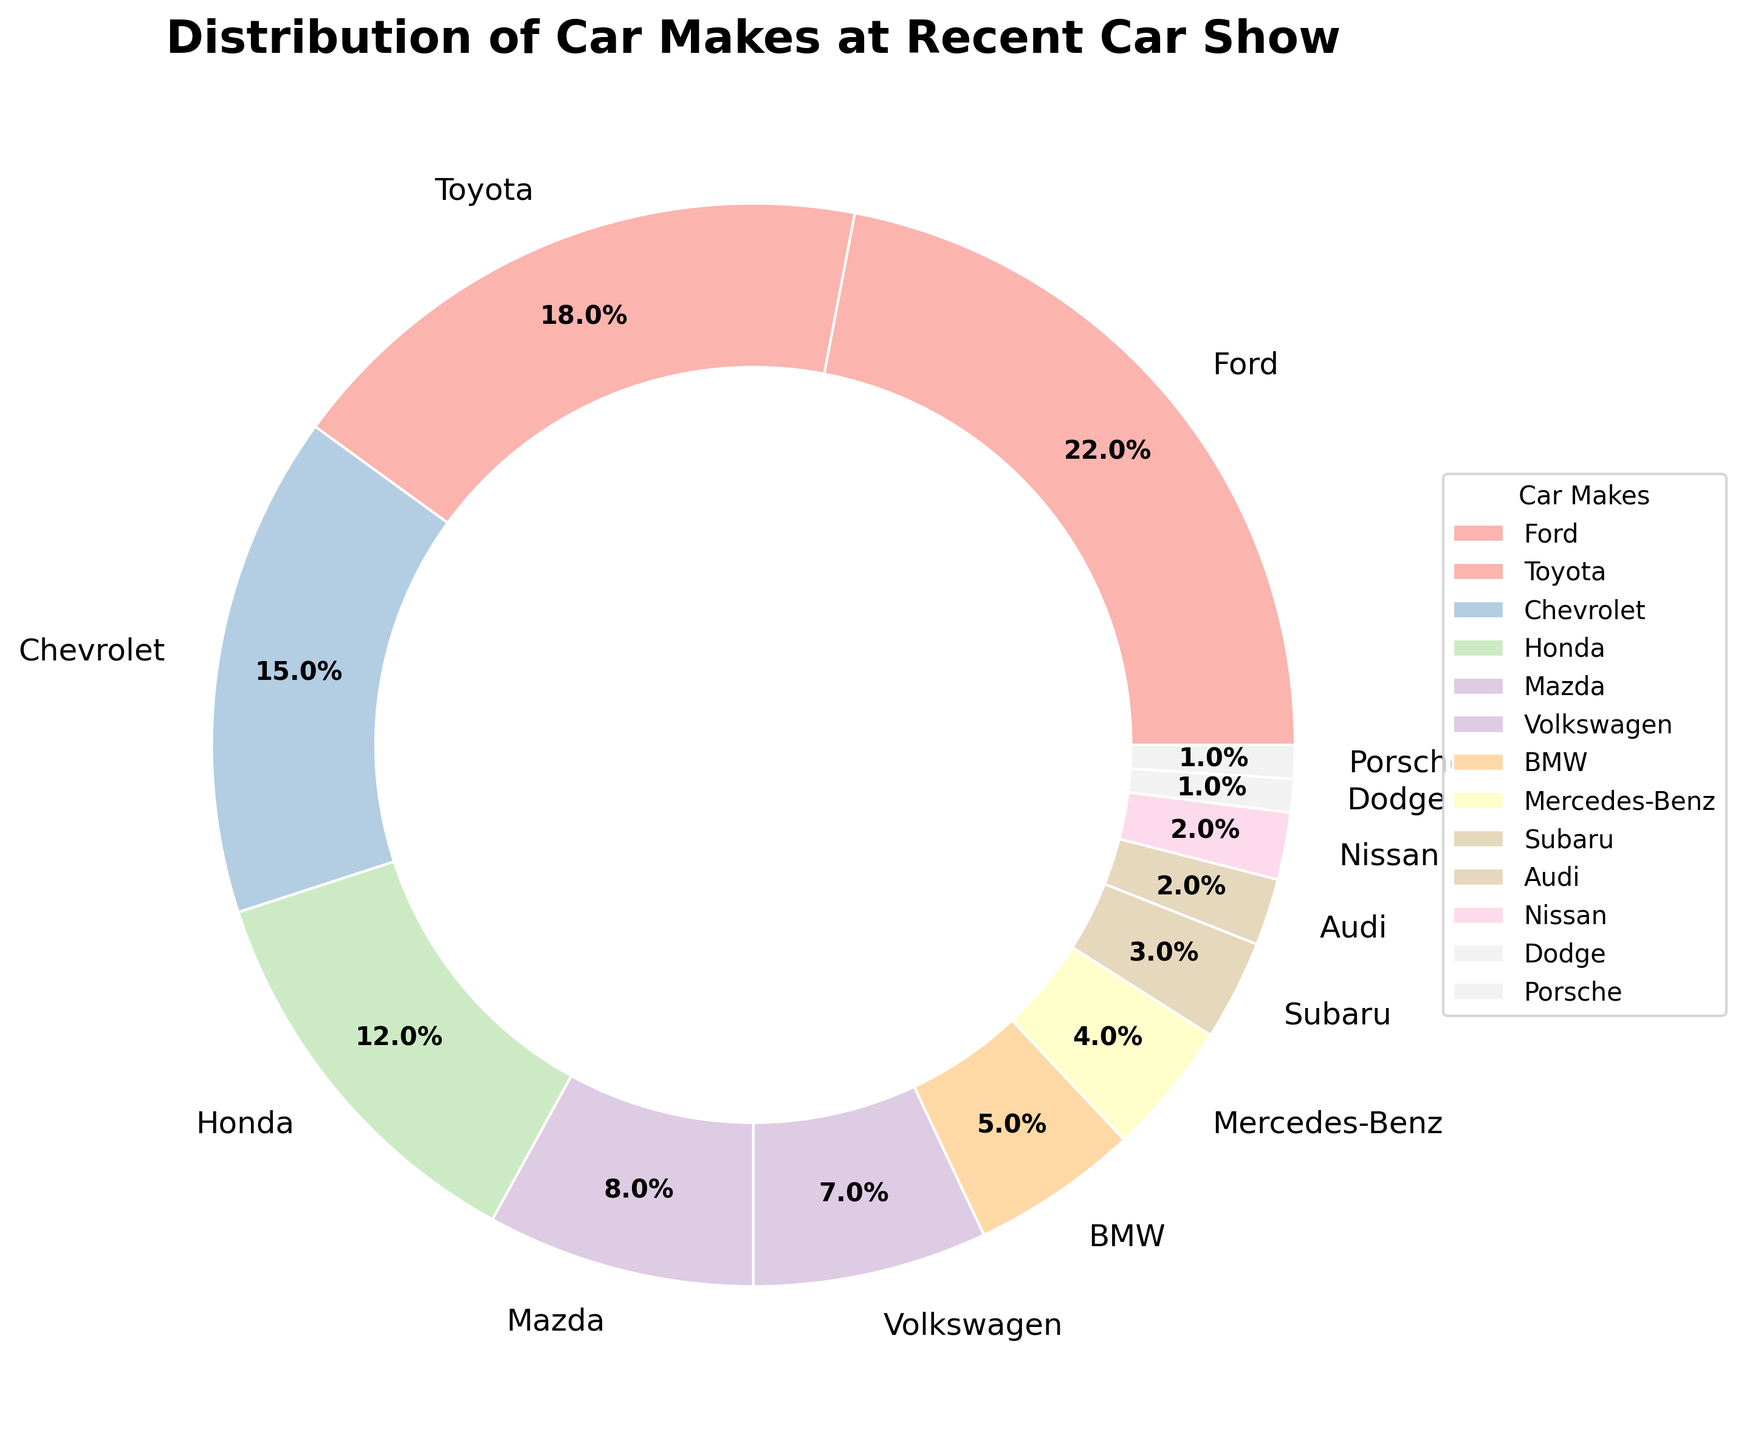Which car make has the largest representation at the car show? Looking at the pie chart, the largest wedge represents Ford. Its size and the percentage label (22%) are the largest among all the car makes.
Answer: Ford How many car makes have a representation of 5% or less? By visually inspecting the pie chart, we can identify the slices with percentages 5% or below: BMW (5%), Mercedes-Benz (4%), Subaru (3%), Audi (2%), Nissan (2%), Dodge (1%), and Porsche (1%). Counting these gives a total of 7 car makes.
Answer: 7 What is the difference in percentage between Ford and Toyota? The percentage for Ford is 22% and for Toyota is 18%. The difference is calculated as 22% - 18% = 4%.
Answer: 4% Which car makes together comprise exactly half of the total cars at the car show? By adding the percentages, we find that Ford (22%) + Toyota (18%) + Chevrolet (15%) = 55%. Individually, none of the combinations of other car makes sum to 50%, so the answer is none.
Answer: None Is the representation of Mazda greater than BMW? The representation of Mazda is 8%, whereas BMW is 5%. Comparatively, Mazda has a higher percentage than BMW.
Answer: Yes How many car makes combined make up 75% of the pie chart? Starting from the largest percentage, we add until reaching 75%: Ford (22%) + Toyota (18%) + Chevrolet (15%) + Honda (12%) + Mazda (8%) totals to 75%. These five car makes together account for 75%.
Answer: 5 What's the percentage difference between the least represented and the most represented car makes? The least represented are Dodge and Porsche at 1%, and the most represented is Ford at 22%. The percentage difference is 22% - 1% = 21%.
Answer: 21% Which car makes contribute to less than 15% representation each? By inspecting the chart, car makes less than 15% include Honda (12%), Mazda (8%), Volkswagen (7%), BMW (5%), Mercedes-Benz (4%), Subaru (3%), Audi (2%), Nissan (2%), Dodge (1%), and Porsche (1%).
Answer: 10 car makes 